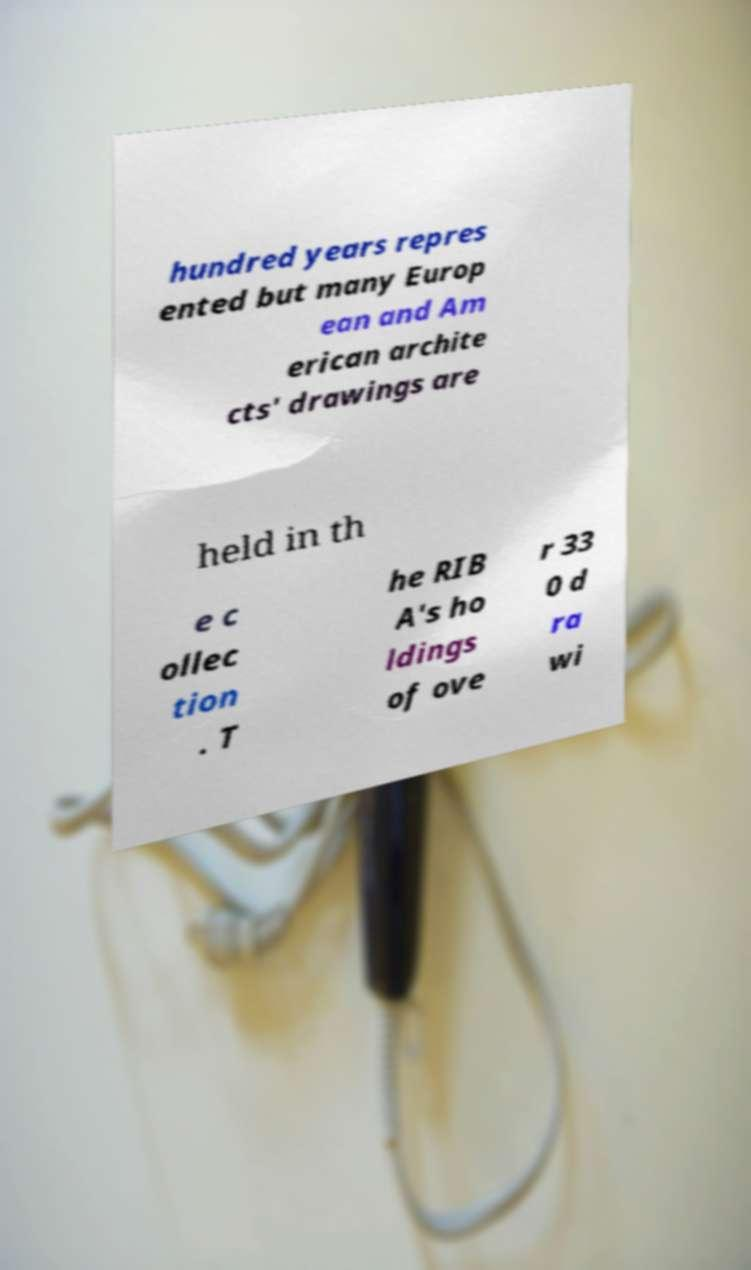For documentation purposes, I need the text within this image transcribed. Could you provide that? hundred years repres ented but many Europ ean and Am erican archite cts' drawings are held in th e c ollec tion . T he RIB A's ho ldings of ove r 33 0 d ra wi 